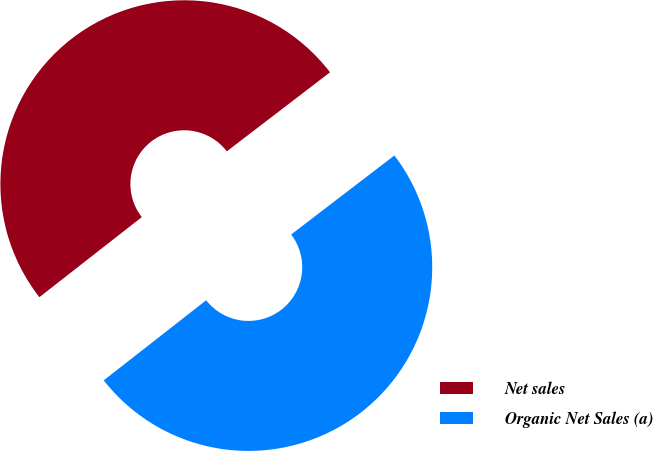Convert chart. <chart><loc_0><loc_0><loc_500><loc_500><pie_chart><fcel>Net sales<fcel>Organic Net Sales (a)<nl><fcel>50.16%<fcel>49.84%<nl></chart> 